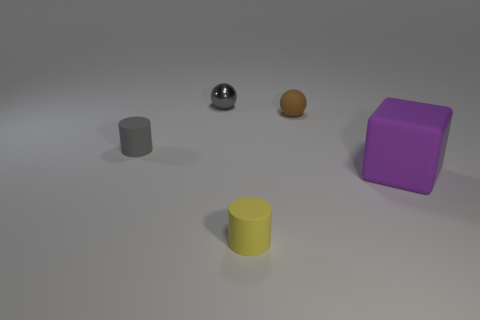Add 3 large purple blocks. How many objects exist? 8 Subtract all cylinders. How many objects are left? 3 Subtract 1 purple blocks. How many objects are left? 4 Subtract all small gray cylinders. Subtract all big purple cubes. How many objects are left? 3 Add 2 cylinders. How many cylinders are left? 4 Add 1 small brown rubber spheres. How many small brown rubber spheres exist? 2 